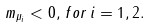<formula> <loc_0><loc_0><loc_500><loc_500>m _ { \mu _ { i } } < 0 , \, f o r \, i = 1 , 2 .</formula> 